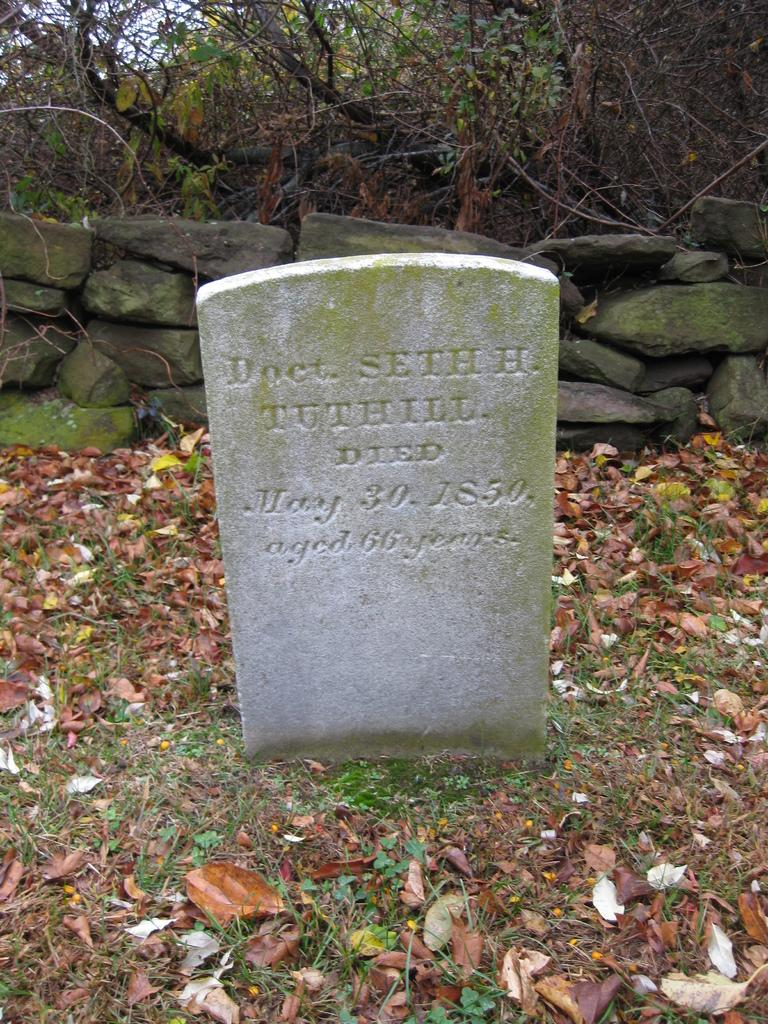What type of location is depicted in the image? There is a cemetery in the image. How is the cemetery situated in relation to the ground? The cemetery is on the ground. What can be seen behind the cemetery? There is a stone wall behind the cemetery. Are there any plants visible in the image? Yes, plants are present near the stone wall. How many attempts were made to wave at the cent in the image? There is no cent or waving depicted in the image; it features a cemetery with a stone wall and plants. 